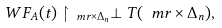<formula> <loc_0><loc_0><loc_500><loc_500>\ W F _ { A } ( t ) \restriction _ { \ m r \times \Delta _ { n } } \perp T ( \ m r \times \Delta _ { n } ) ,</formula> 